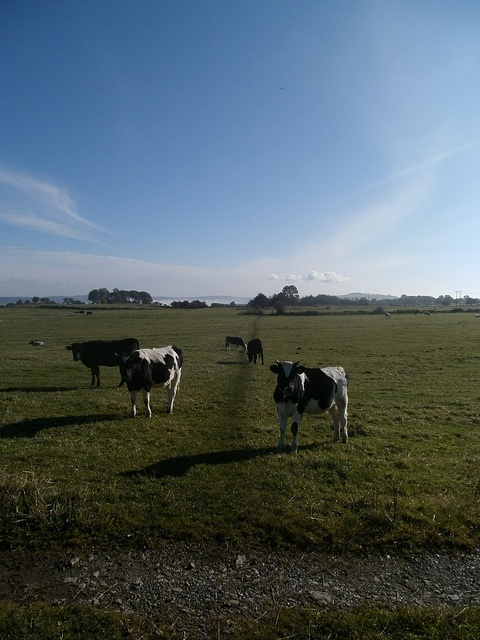Describe the objects in this image and their specific colors. I can see cow in darkblue, black, darkgray, gray, and darkgreen tones, cow in darkblue, black, darkgray, gray, and darkgreen tones, cow in darkblue, black, darkgreen, and gray tones, cow in darkblue, black, darkgreen, and gray tones, and cow in darkblue, black, and gray tones in this image. 